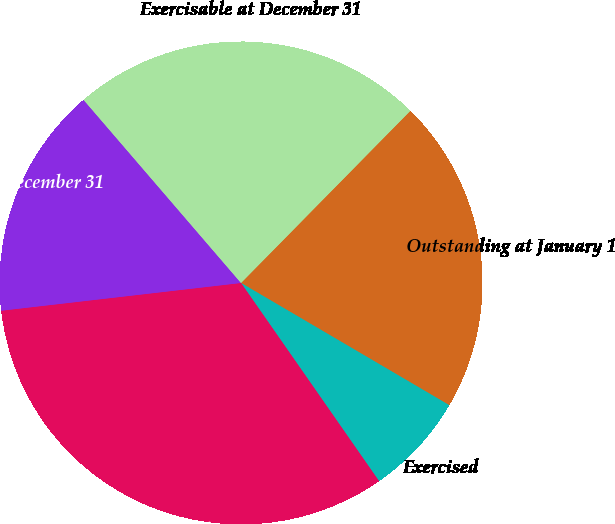<chart> <loc_0><loc_0><loc_500><loc_500><pie_chart><fcel>Outstanding at January 1<fcel>Exercised<fcel>Forfeited or Expired<fcel>Outstanding at December 31<fcel>Exercisable at December 31<nl><fcel>21.08%<fcel>6.87%<fcel>32.85%<fcel>15.53%<fcel>23.67%<nl></chart> 